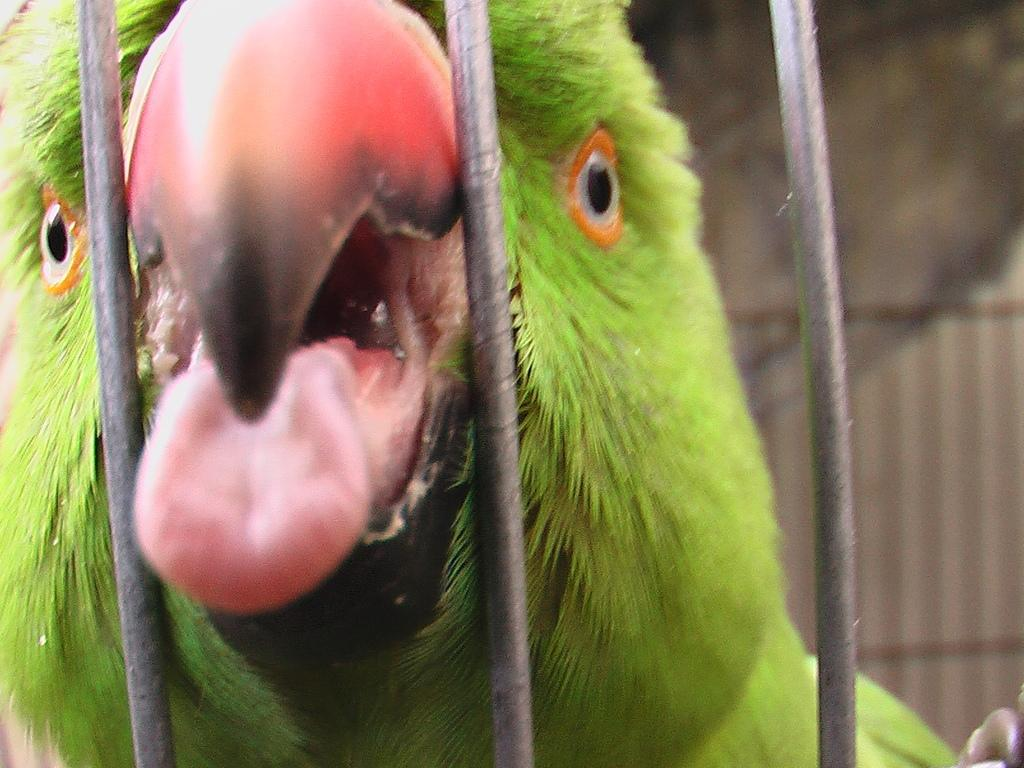What type of animal is in the image? There is a green parrot in the image. What is the parrot doing in the image? The parrot's mouth is open. Where is the parrot located in the image? The parrot is in an iron cage. What can be seen in the background of the image? There is a wall in the background of the image. What type of van can be seen parked next to the parrot's cage in the image? There is no van present in the image; it only features a green parrot in an iron cage with a wall in the background. 